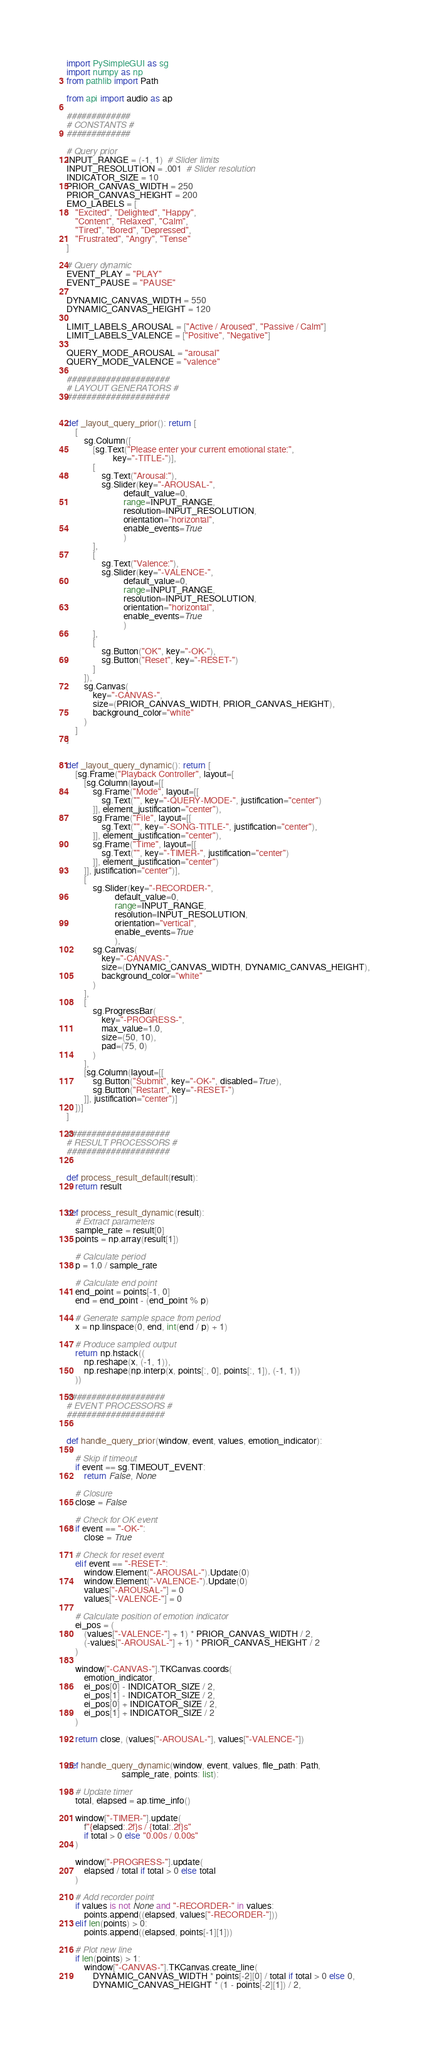Convert code to text. <code><loc_0><loc_0><loc_500><loc_500><_Python_>import PySimpleGUI as sg
import numpy as np
from pathlib import Path

from api import audio as ap

#############
# CONSTANTS #
#############

# Query prior
INPUT_RANGE = (-1, 1)  # Slider limits
INPUT_RESOLUTION = .001  # Slider resolution
INDICATOR_SIZE = 10
PRIOR_CANVAS_WIDTH = 250
PRIOR_CANVAS_HEIGHT = 200
EMO_LABELS = [
    "Excited", "Delighted", "Happy",
    "Content", "Relaxed", "Calm",
    "Tired", "Bored", "Depressed",
    "Frustrated", "Angry", "Tense"
]

# Query dynamic
EVENT_PLAY = "PLAY"
EVENT_PAUSE = "PAUSE"

DYNAMIC_CANVAS_WIDTH = 550
DYNAMIC_CANVAS_HEIGHT = 120

LIMIT_LABELS_AROUSAL = ["Active / Aroused", "Passive / Calm"]
LIMIT_LABELS_VALENCE = ["Positive", "Negative"]

QUERY_MODE_AROUSAL = "arousal"
QUERY_MODE_VALENCE = "valence"

#####################
# LAYOUT GENERATORS #
#####################


def _layout_query_prior(): return [
    [
        sg.Column([
            [sg.Text("Please enter your current emotional state:",
                     key="-TITLE-")],
            [
                sg.Text("Arousal:"),
                sg.Slider(key="-AROUSAL-",
                          default_value=0,
                          range=INPUT_RANGE,
                          resolution=INPUT_RESOLUTION,
                          orientation="horizontal",
                          enable_events=True
                          )
            ],
            [
                sg.Text("Valence:"),
                sg.Slider(key="-VALENCE-",
                          default_value=0,
                          range=INPUT_RANGE,
                          resolution=INPUT_RESOLUTION,
                          orientation="horizontal",
                          enable_events=True
                          )
            ],
            [
                sg.Button("OK", key="-OK-"),
                sg.Button("Reset", key="-RESET-")
            ]
        ]),
        sg.Canvas(
            key="-CANVAS-",
            size=(PRIOR_CANVAS_WIDTH, PRIOR_CANVAS_HEIGHT),
            background_color="white"
        )
    ]
]


def _layout_query_dynamic(): return [
    [sg.Frame("Playback Controller", layout=[
        [sg.Column(layout=[[
            sg.Frame("Mode", layout=[[
                sg.Text("", key="-QUERY-MODE-", justification="center")
            ]], element_justification="center"),
            sg.Frame("File", layout=[[
                sg.Text("", key="-SONG-TITLE-", justification="center"),
            ]], element_justification="center"),
            sg.Frame("Time", layout=[[
                sg.Text("", key="-TIMER-", justification="center")
            ]], element_justification="center")
        ]], justification="center")],
        [
            sg.Slider(key="-RECORDER-",
                      default_value=0,
                      range=INPUT_RANGE,
                      resolution=INPUT_RESOLUTION,
                      orientation="vertical",
                      enable_events=True
                      ),
            sg.Canvas(
                key="-CANVAS-",
                size=(DYNAMIC_CANVAS_WIDTH, DYNAMIC_CANVAS_HEIGHT),
                background_color="white"
            )
        ],
        [
            sg.ProgressBar(
                key="-PROGRESS-",
                max_value=1.0,
                size=(50, 10),
                pad=(75, 0)
            )
        ],
        [sg.Column(layout=[[
            sg.Button("Submit", key="-OK-", disabled=True),
            sg.Button("Restart", key="-RESET-")
        ]], justification="center")]
    ])]
]

#####################
# RESULT PROCESSORS #
#####################


def process_result_default(result):
    return result


def process_result_dynamic(result):
    # Extract parameters
    sample_rate = result[0]
    points = np.array(result[1])

    # Calculate period
    p = 1.0 / sample_rate

    # Calculate end point
    end_point = points[-1, 0]
    end = end_point - (end_point % p)

    # Generate sample space from period
    x = np.linspace(0, end, int(end / p) + 1)

    # Produce sampled output
    return np.hstack((
        np.reshape(x, (-1, 1)),
        np.reshape(np.interp(x, points[:, 0], points[:, 1]), (-1, 1))
    ))

####################
# EVENT PROCESSORS #
####################


def handle_query_prior(window, event, values, emotion_indicator):

    # Skip if timeout
    if event == sg.TIMEOUT_EVENT:
        return False, None

    # Closure
    close = False

    # Check for OK event
    if event == "-OK-":
        close = True

    # Check for reset event
    elif event == "-RESET-":
        window.Element("-AROUSAL-").Update(0)
        window.Element("-VALENCE-").Update(0)
        values["-AROUSAL-"] = 0
        values["-VALENCE-"] = 0

    # Calculate position of emotion indicator
    ei_pos = (
        (values["-VALENCE-"] + 1) * PRIOR_CANVAS_WIDTH / 2,
        (-values["-AROUSAL-"] + 1) * PRIOR_CANVAS_HEIGHT / 2
    )

    window["-CANVAS-"].TKCanvas.coords(
        emotion_indicator,
        ei_pos[0] - INDICATOR_SIZE / 2,
        ei_pos[1] - INDICATOR_SIZE / 2,
        ei_pos[0] + INDICATOR_SIZE / 2,
        ei_pos[1] + INDICATOR_SIZE / 2
    )

    return close, (values["-AROUSAL-"], values["-VALENCE-"])


def handle_query_dynamic(window, event, values, file_path: Path,
                         sample_rate, points: list):

    # Update timer
    total, elapsed = ap.time_info()

    window["-TIMER-"].update(
        f"{elapsed:.2f}s / {total:.2f}s"
        if total > 0 else "0.00s / 0.00s"
    )

    window["-PROGRESS-"].update(
        elapsed / total if total > 0 else total
    )

    # Add recorder point
    if values is not None and "-RECORDER-" in values:
        points.append((elapsed, values["-RECORDER-"]))
    elif len(points) > 0:
        points.append((elapsed, points[-1][1]))

    # Plot new line
    if len(points) > 1:
        window["-CANVAS-"].TKCanvas.create_line(
            DYNAMIC_CANVAS_WIDTH * points[-2][0] / total if total > 0 else 0,
            DYNAMIC_CANVAS_HEIGHT * (1 - points[-2][1]) / 2,</code> 